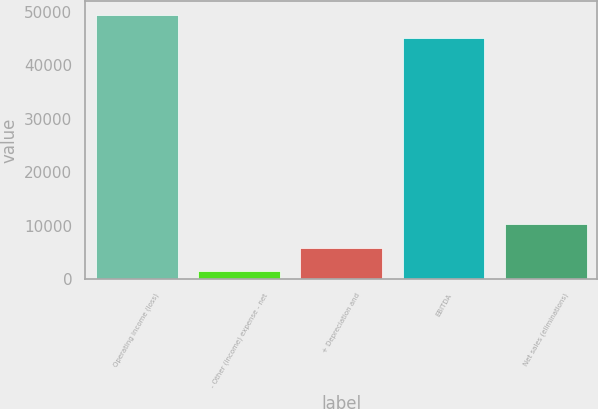Convert chart. <chart><loc_0><loc_0><loc_500><loc_500><bar_chart><fcel>Operating income (loss)<fcel>- Other (income) expense - net<fcel>+ Depreciation and<fcel>EBITDA<fcel>Net sales (eliminations)<nl><fcel>49467.9<fcel>1550<fcel>5908.9<fcel>45109<fcel>10267.8<nl></chart> 